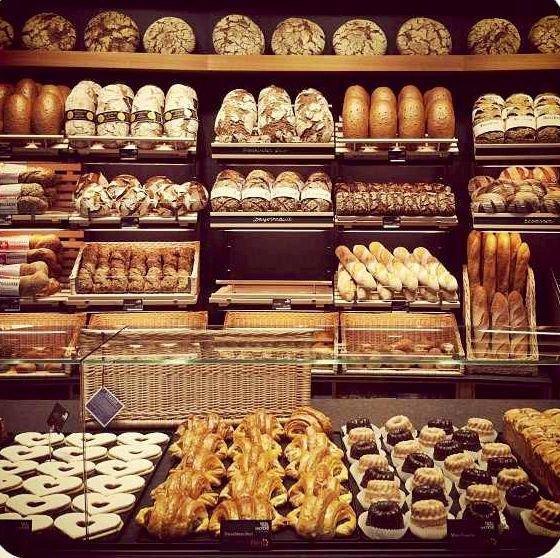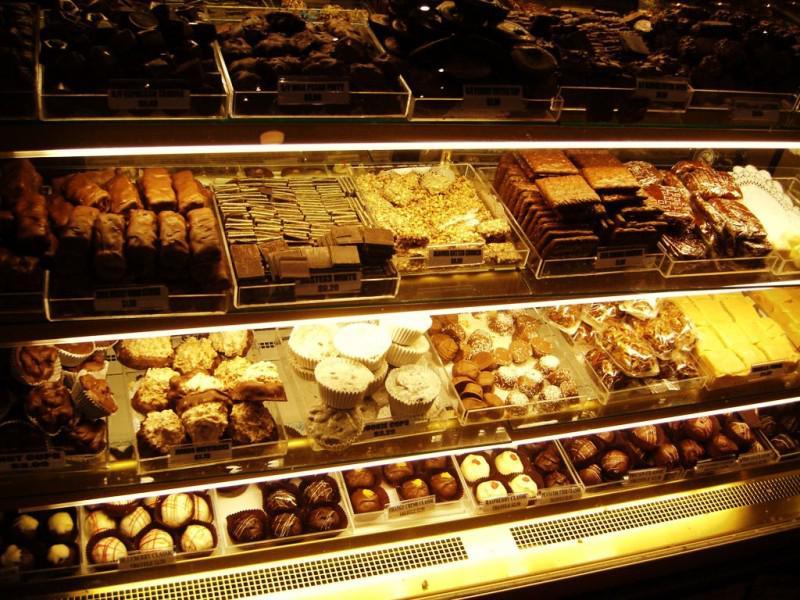The first image is the image on the left, the second image is the image on the right. Assess this claim about the two images: "At least one person is near bread products in one image.". Correct or not? Answer yes or no. No. The first image is the image on the left, the second image is the image on the right. Examine the images to the left and right. Is the description "There is at least one purple label in one of the images." accurate? Answer yes or no. Yes. The first image is the image on the left, the second image is the image on the right. Considering the images on both sides, is "At least one image includes lights above the bakery displays." valid? Answer yes or no. No. 